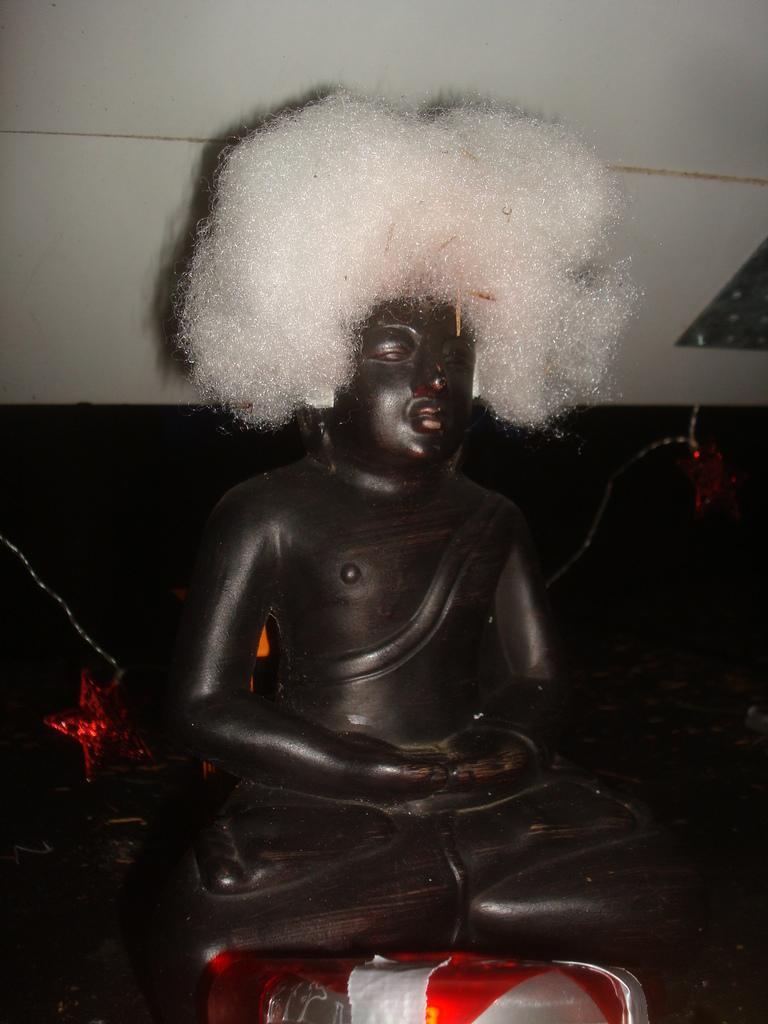How would you summarize this image in a sentence or two? Here we can see a statue and there is an object. In the background we can see wall. 